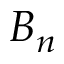Convert formula to latex. <formula><loc_0><loc_0><loc_500><loc_500>B _ { n }</formula> 